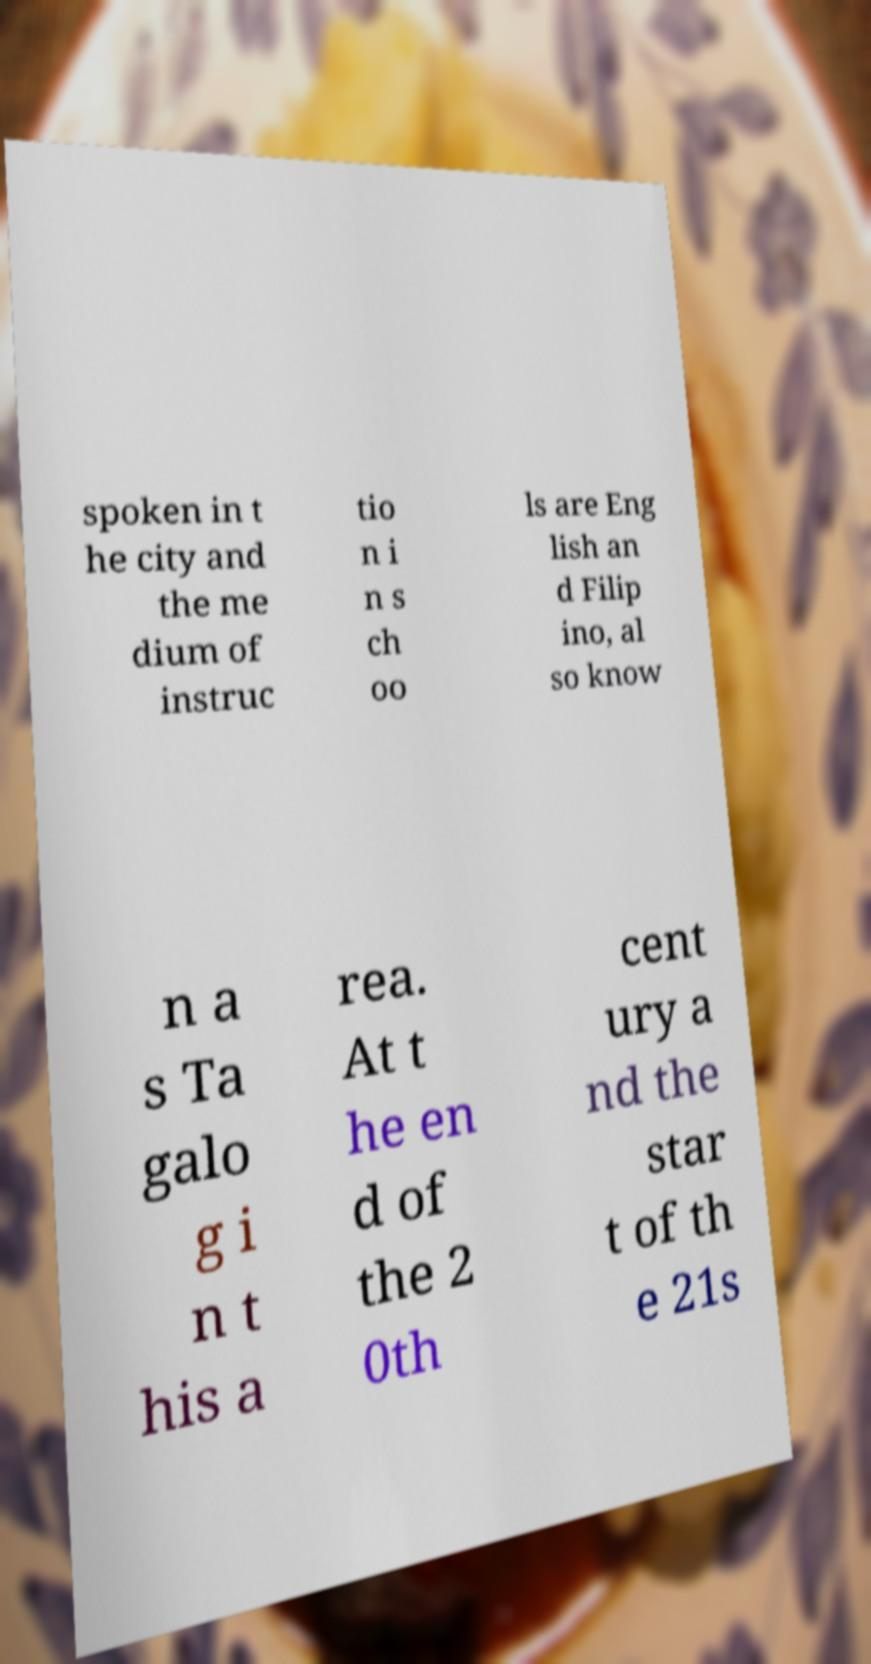Can you read and provide the text displayed in the image?This photo seems to have some interesting text. Can you extract and type it out for me? spoken in t he city and the me dium of instruc tio n i n s ch oo ls are Eng lish an d Filip ino, al so know n a s Ta galo g i n t his a rea. At t he en d of the 2 0th cent ury a nd the star t of th e 21s 